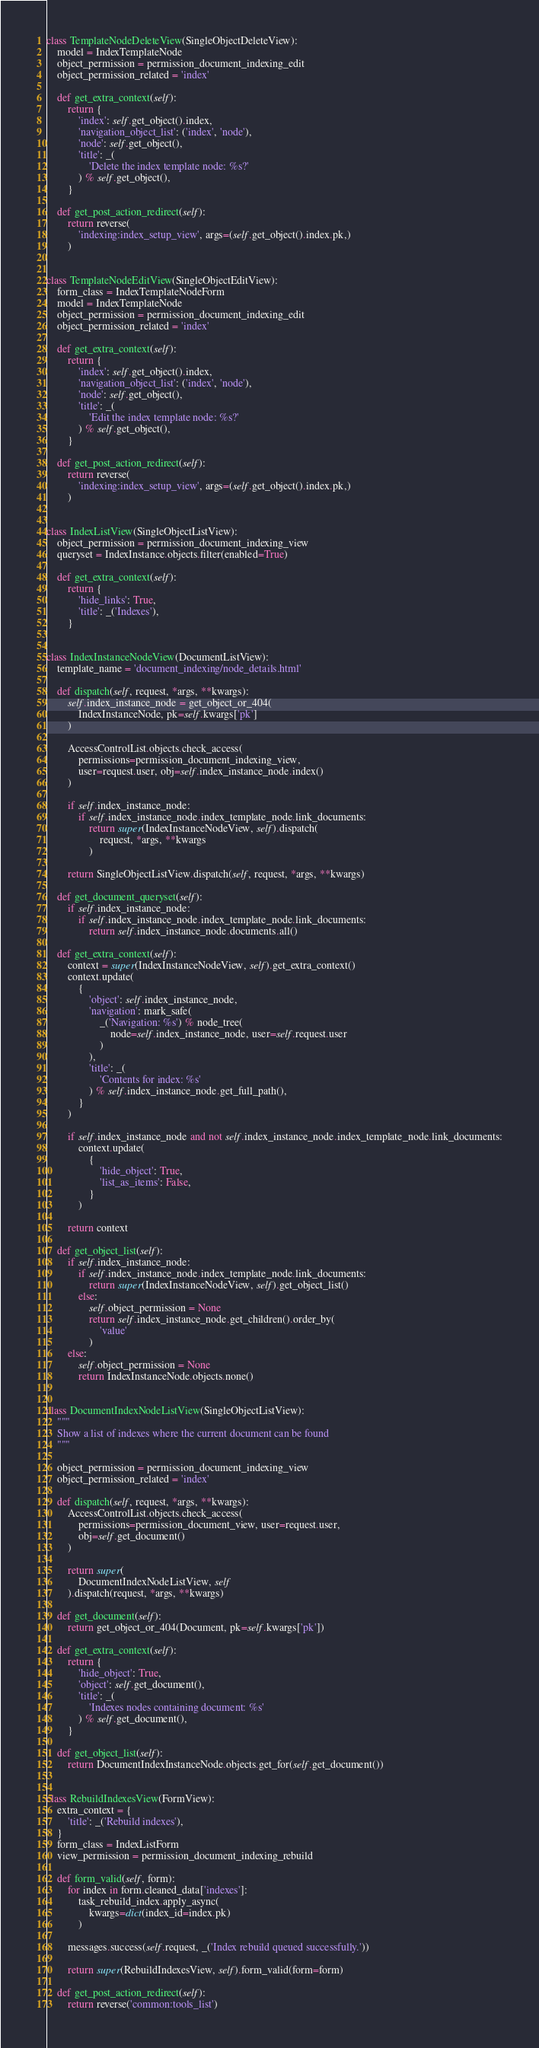<code> <loc_0><loc_0><loc_500><loc_500><_Python_>

class TemplateNodeDeleteView(SingleObjectDeleteView):
    model = IndexTemplateNode
    object_permission = permission_document_indexing_edit
    object_permission_related = 'index'

    def get_extra_context(self):
        return {
            'index': self.get_object().index,
            'navigation_object_list': ('index', 'node'),
            'node': self.get_object(),
            'title': _(
                'Delete the index template node: %s?'
            ) % self.get_object(),
        }

    def get_post_action_redirect(self):
        return reverse(
            'indexing:index_setup_view', args=(self.get_object().index.pk,)
        )


class TemplateNodeEditView(SingleObjectEditView):
    form_class = IndexTemplateNodeForm
    model = IndexTemplateNode
    object_permission = permission_document_indexing_edit
    object_permission_related = 'index'

    def get_extra_context(self):
        return {
            'index': self.get_object().index,
            'navigation_object_list': ('index', 'node'),
            'node': self.get_object(),
            'title': _(
                'Edit the index template node: %s?'
            ) % self.get_object(),
        }

    def get_post_action_redirect(self):
        return reverse(
            'indexing:index_setup_view', args=(self.get_object().index.pk,)
        )


class IndexListView(SingleObjectListView):
    object_permission = permission_document_indexing_view
    queryset = IndexInstance.objects.filter(enabled=True)

    def get_extra_context(self):
        return {
            'hide_links': True,
            'title': _('Indexes'),
        }


class IndexInstanceNodeView(DocumentListView):
    template_name = 'document_indexing/node_details.html'

    def dispatch(self, request, *args, **kwargs):
        self.index_instance_node = get_object_or_404(
            IndexInstanceNode, pk=self.kwargs['pk']
        )

        AccessControlList.objects.check_access(
            permissions=permission_document_indexing_view,
            user=request.user, obj=self.index_instance_node.index()
        )

        if self.index_instance_node:
            if self.index_instance_node.index_template_node.link_documents:
                return super(IndexInstanceNodeView, self).dispatch(
                    request, *args, **kwargs
                )

        return SingleObjectListView.dispatch(self, request, *args, **kwargs)

    def get_document_queryset(self):
        if self.index_instance_node:
            if self.index_instance_node.index_template_node.link_documents:
                return self.index_instance_node.documents.all()

    def get_extra_context(self):
        context = super(IndexInstanceNodeView, self).get_extra_context()
        context.update(
            {
                'object': self.index_instance_node,
                'navigation': mark_safe(
                    _('Navigation: %s') % node_tree(
                        node=self.index_instance_node, user=self.request.user
                    )
                ),
                'title': _(
                    'Contents for index: %s'
                ) % self.index_instance_node.get_full_path(),
            }
        )

        if self.index_instance_node and not self.index_instance_node.index_template_node.link_documents:
            context.update(
                {
                    'hide_object': True,
                    'list_as_items': False,
                }
            )

        return context

    def get_object_list(self):
        if self.index_instance_node:
            if self.index_instance_node.index_template_node.link_documents:
                return super(IndexInstanceNodeView, self).get_object_list()
            else:
                self.object_permission = None
                return self.index_instance_node.get_children().order_by(
                    'value'
                )
        else:
            self.object_permission = None
            return IndexInstanceNode.objects.none()


class DocumentIndexNodeListView(SingleObjectListView):
    """
    Show a list of indexes where the current document can be found
    """

    object_permission = permission_document_indexing_view
    object_permission_related = 'index'

    def dispatch(self, request, *args, **kwargs):
        AccessControlList.objects.check_access(
            permissions=permission_document_view, user=request.user,
            obj=self.get_document()
        )

        return super(
            DocumentIndexNodeListView, self
        ).dispatch(request, *args, **kwargs)

    def get_document(self):
        return get_object_or_404(Document, pk=self.kwargs['pk'])

    def get_extra_context(self):
        return {
            'hide_object': True,
            'object': self.get_document(),
            'title': _(
                'Indexes nodes containing document: %s'
            ) % self.get_document(),
        }

    def get_object_list(self):
        return DocumentIndexInstanceNode.objects.get_for(self.get_document())


class RebuildIndexesView(FormView):
    extra_context = {
        'title': _('Rebuild indexes'),
    }
    form_class = IndexListForm
    view_permission = permission_document_indexing_rebuild

    def form_valid(self, form):
        for index in form.cleaned_data['indexes']:
            task_rebuild_index.apply_async(
                kwargs=dict(index_id=index.pk)
            )

        messages.success(self.request, _('Index rebuild queued successfully.'))

        return super(RebuildIndexesView, self).form_valid(form=form)

    def get_post_action_redirect(self):
        return reverse('common:tools_list')
</code> 